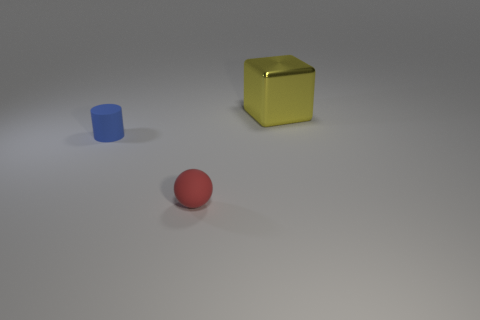Add 1 blue cylinders. How many objects exist? 4 Subtract all blocks. How many objects are left? 2 Subtract 0 green blocks. How many objects are left? 3 Subtract all big yellow things. Subtract all small blue rubber cylinders. How many objects are left? 1 Add 1 tiny things. How many tiny things are left? 3 Add 3 large cyan matte things. How many large cyan matte things exist? 3 